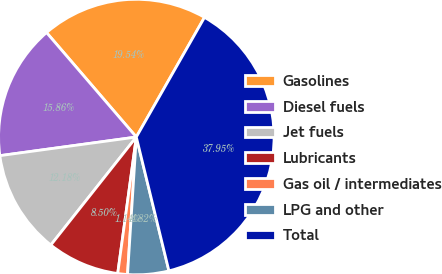Convert chart. <chart><loc_0><loc_0><loc_500><loc_500><pie_chart><fcel>Gasolines<fcel>Diesel fuels<fcel>Jet fuels<fcel>Lubricants<fcel>Gas oil / intermediates<fcel>LPG and other<fcel>Total<nl><fcel>19.54%<fcel>15.86%<fcel>12.18%<fcel>8.5%<fcel>1.14%<fcel>4.82%<fcel>37.95%<nl></chart> 